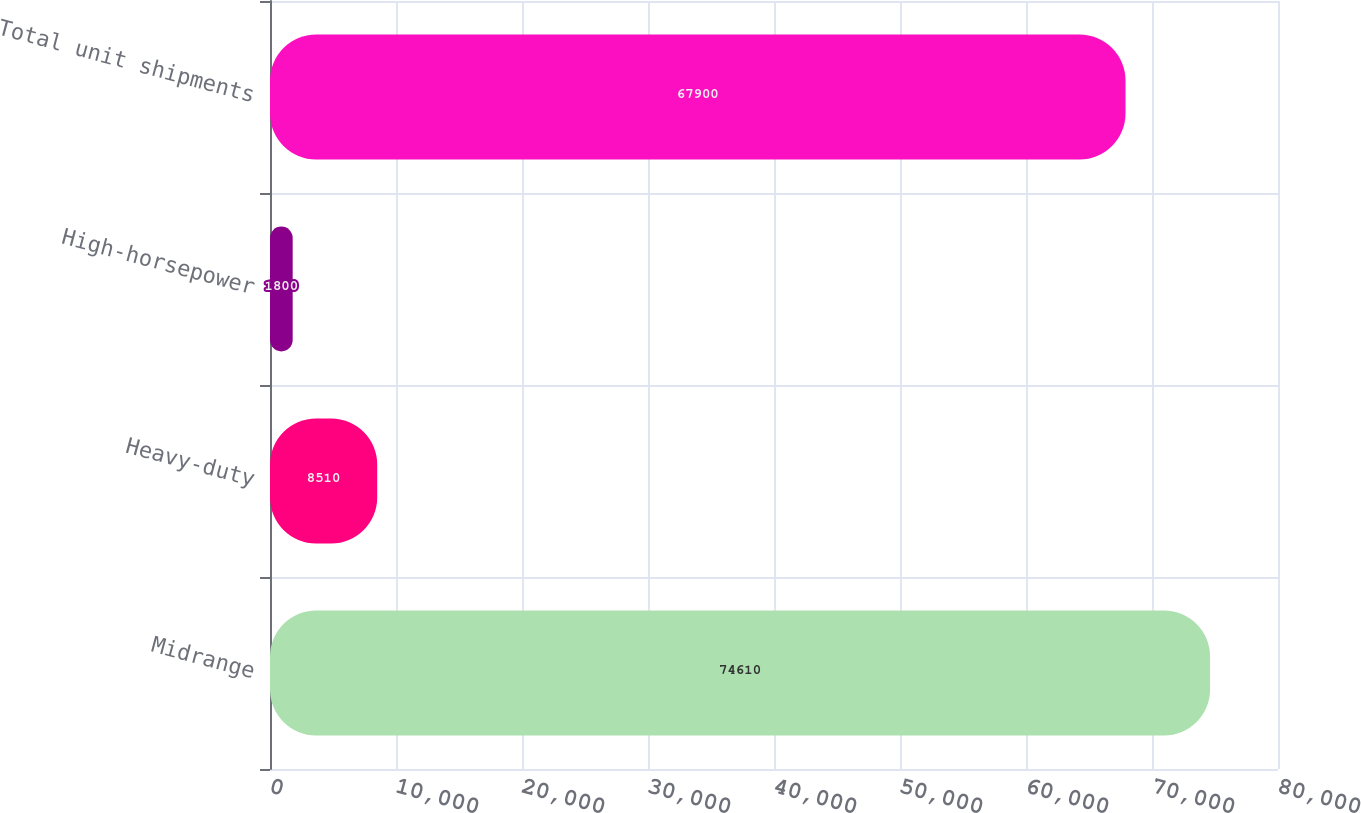Convert chart to OTSL. <chart><loc_0><loc_0><loc_500><loc_500><bar_chart><fcel>Midrange<fcel>Heavy-duty<fcel>High-horsepower<fcel>Total unit shipments<nl><fcel>74610<fcel>8510<fcel>1800<fcel>67900<nl></chart> 